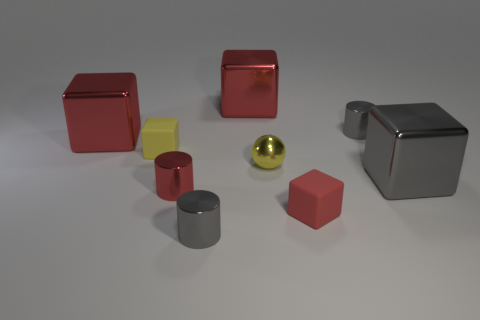What is the material of the tiny cube that is on the left side of the small rubber block that is to the right of the yellow matte block?
Give a very brief answer. Rubber. There is a gray shiny thing that is the same shape as the small red matte thing; what is its size?
Provide a short and direct response. Large. There is a metal thing that is both behind the metallic sphere and on the right side of the tiny yellow sphere; what is its color?
Make the answer very short. Gray. Is the size of the gray metal thing that is behind the gray shiny cube the same as the large gray metal thing?
Your response must be concise. No. Is there anything else that is the same shape as the yellow rubber object?
Ensure brevity in your answer.  Yes. Are the gray block and the gray object to the left of the ball made of the same material?
Your response must be concise. Yes. What number of red things are either small spheres or large blocks?
Make the answer very short. 2. Are there any small green matte cylinders?
Give a very brief answer. No. There is a small yellow thing that is behind the yellow shiny object that is behind the small red matte thing; is there a large metal thing behind it?
Your answer should be very brief. Yes. There is a red rubber thing; is it the same shape as the small rubber thing that is left of the red rubber object?
Give a very brief answer. Yes. 